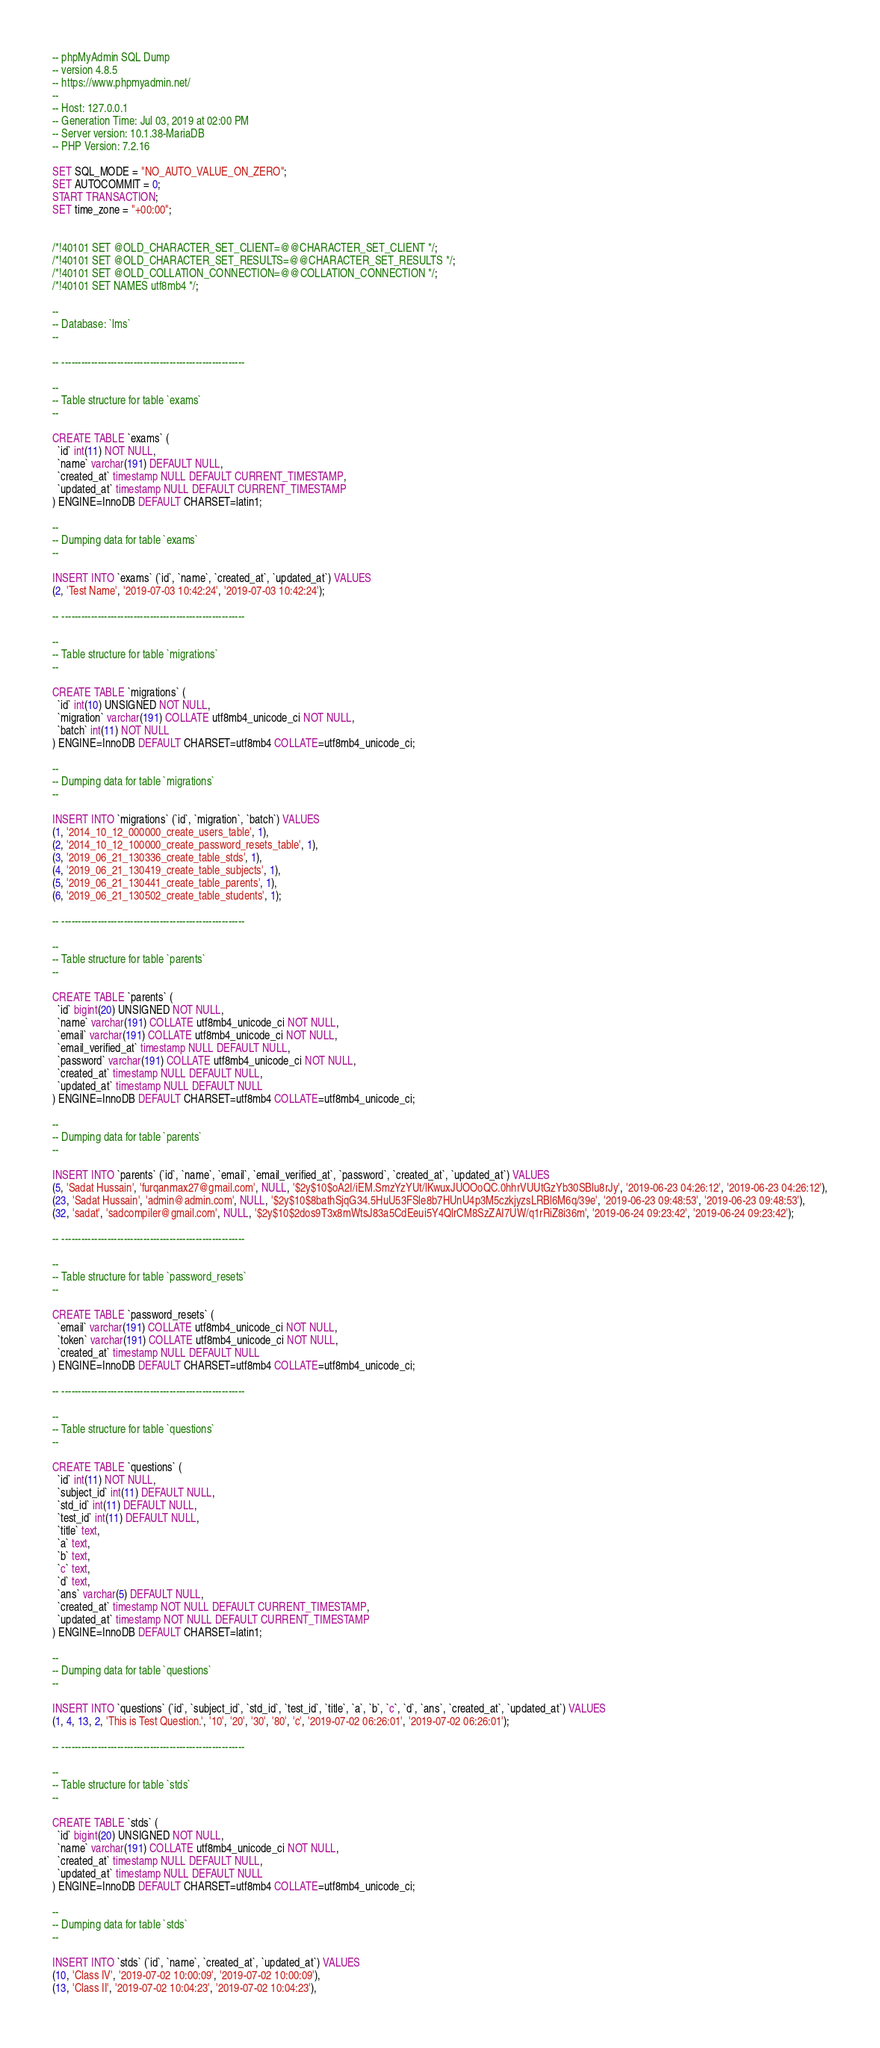<code> <loc_0><loc_0><loc_500><loc_500><_SQL_>-- phpMyAdmin SQL Dump
-- version 4.8.5
-- https://www.phpmyadmin.net/
--
-- Host: 127.0.0.1
-- Generation Time: Jul 03, 2019 at 02:00 PM
-- Server version: 10.1.38-MariaDB
-- PHP Version: 7.2.16

SET SQL_MODE = "NO_AUTO_VALUE_ON_ZERO";
SET AUTOCOMMIT = 0;
START TRANSACTION;
SET time_zone = "+00:00";


/*!40101 SET @OLD_CHARACTER_SET_CLIENT=@@CHARACTER_SET_CLIENT */;
/*!40101 SET @OLD_CHARACTER_SET_RESULTS=@@CHARACTER_SET_RESULTS */;
/*!40101 SET @OLD_COLLATION_CONNECTION=@@COLLATION_CONNECTION */;
/*!40101 SET NAMES utf8mb4 */;

--
-- Database: `lms`
--

-- --------------------------------------------------------

--
-- Table structure for table `exams`
--

CREATE TABLE `exams` (
  `id` int(11) NOT NULL,
  `name` varchar(191) DEFAULT NULL,
  `created_at` timestamp NULL DEFAULT CURRENT_TIMESTAMP,
  `updated_at` timestamp NULL DEFAULT CURRENT_TIMESTAMP
) ENGINE=InnoDB DEFAULT CHARSET=latin1;

--
-- Dumping data for table `exams`
--

INSERT INTO `exams` (`id`, `name`, `created_at`, `updated_at`) VALUES
(2, 'Test Name', '2019-07-03 10:42:24', '2019-07-03 10:42:24');

-- --------------------------------------------------------

--
-- Table structure for table `migrations`
--

CREATE TABLE `migrations` (
  `id` int(10) UNSIGNED NOT NULL,
  `migration` varchar(191) COLLATE utf8mb4_unicode_ci NOT NULL,
  `batch` int(11) NOT NULL
) ENGINE=InnoDB DEFAULT CHARSET=utf8mb4 COLLATE=utf8mb4_unicode_ci;

--
-- Dumping data for table `migrations`
--

INSERT INTO `migrations` (`id`, `migration`, `batch`) VALUES
(1, '2014_10_12_000000_create_users_table', 1),
(2, '2014_10_12_100000_create_password_resets_table', 1),
(3, '2019_06_21_130336_create_table_stds', 1),
(4, '2019_06_21_130419_create_table_subjects', 1),
(5, '2019_06_21_130441_create_table_parents', 1),
(6, '2019_06_21_130502_create_table_students', 1);

-- --------------------------------------------------------

--
-- Table structure for table `parents`
--

CREATE TABLE `parents` (
  `id` bigint(20) UNSIGNED NOT NULL,
  `name` varchar(191) COLLATE utf8mb4_unicode_ci NOT NULL,
  `email` varchar(191) COLLATE utf8mb4_unicode_ci NOT NULL,
  `email_verified_at` timestamp NULL DEFAULT NULL,
  `password` varchar(191) COLLATE utf8mb4_unicode_ci NOT NULL,
  `created_at` timestamp NULL DEFAULT NULL,
  `updated_at` timestamp NULL DEFAULT NULL
) ENGINE=InnoDB DEFAULT CHARSET=utf8mb4 COLLATE=utf8mb4_unicode_ci;

--
-- Dumping data for table `parents`
--

INSERT INTO `parents` (`id`, `name`, `email`, `email_verified_at`, `password`, `created_at`, `updated_at`) VALUES
(5, 'Sadat Hussain', 'furqanmax27@gmail.com', NULL, '$2y$10$oA2I/iEM.SmzYzYUt/lKwuxJUOOoQC.0hhrVUUtGzYb30SBlu8rJy', '2019-06-23 04:26:12', '2019-06-23 04:26:12'),
(23, 'Sadat Hussain', 'admin@admin.com', NULL, '$2y$10$8bathSjqG34.5HuU53FSle8b7HUnU4p3M5czkjyzsLRBl6M6q/39e', '2019-06-23 09:48:53', '2019-06-23 09:48:53'),
(32, 'sadat', 'sadcompiler@gmail.com', NULL, '$2y$10$2dos9T3x8mWtsJ83a5CdEeui5Y4QlrCM8SzZAI7UW/q1rRiZ8i36m', '2019-06-24 09:23:42', '2019-06-24 09:23:42');

-- --------------------------------------------------------

--
-- Table structure for table `password_resets`
--

CREATE TABLE `password_resets` (
  `email` varchar(191) COLLATE utf8mb4_unicode_ci NOT NULL,
  `token` varchar(191) COLLATE utf8mb4_unicode_ci NOT NULL,
  `created_at` timestamp NULL DEFAULT NULL
) ENGINE=InnoDB DEFAULT CHARSET=utf8mb4 COLLATE=utf8mb4_unicode_ci;

-- --------------------------------------------------------

--
-- Table structure for table `questions`
--

CREATE TABLE `questions` (
  `id` int(11) NOT NULL,
  `subject_id` int(11) DEFAULT NULL,
  `std_id` int(11) DEFAULT NULL,
  `test_id` int(11) DEFAULT NULL,
  `title` text,
  `a` text,
  `b` text,
  `c` text,
  `d` text,
  `ans` varchar(5) DEFAULT NULL,
  `created_at` timestamp NOT NULL DEFAULT CURRENT_TIMESTAMP,
  `updated_at` timestamp NOT NULL DEFAULT CURRENT_TIMESTAMP
) ENGINE=InnoDB DEFAULT CHARSET=latin1;

--
-- Dumping data for table `questions`
--

INSERT INTO `questions` (`id`, `subject_id`, `std_id`, `test_id`, `title`, `a`, `b`, `c`, `d`, `ans`, `created_at`, `updated_at`) VALUES
(1, 4, 13, 2, 'This is Test Question.', '10', '20', '30', '80', 'c', '2019-07-02 06:26:01', '2019-07-02 06:26:01');

-- --------------------------------------------------------

--
-- Table structure for table `stds`
--

CREATE TABLE `stds` (
  `id` bigint(20) UNSIGNED NOT NULL,
  `name` varchar(191) COLLATE utf8mb4_unicode_ci NOT NULL,
  `created_at` timestamp NULL DEFAULT NULL,
  `updated_at` timestamp NULL DEFAULT NULL
) ENGINE=InnoDB DEFAULT CHARSET=utf8mb4 COLLATE=utf8mb4_unicode_ci;

--
-- Dumping data for table `stds`
--

INSERT INTO `stds` (`id`, `name`, `created_at`, `updated_at`) VALUES
(10, 'Class IV', '2019-07-02 10:00:09', '2019-07-02 10:00:09'),
(13, 'Class II', '2019-07-02 10:04:23', '2019-07-02 10:04:23'),</code> 